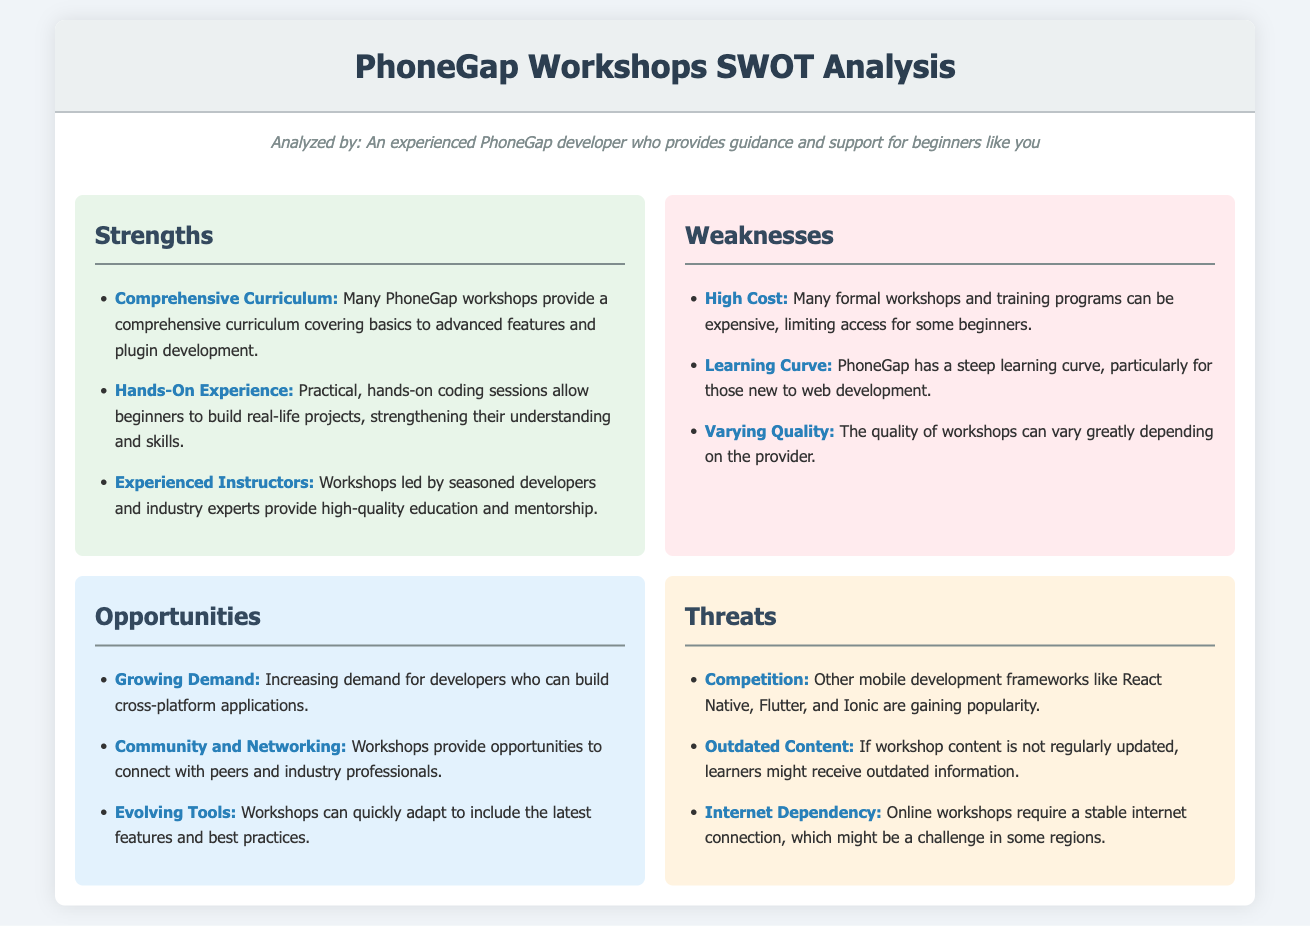What are the strengths listed in the SWOT analysis? The strengths section contains three main points about the workshops: comprehensive curriculum, hands-on experience, and experienced instructors.
Answer: Comprehensive Curriculum, Hands-On Experience, Experienced Instructors What is a listed weakness regarding the workshops? One of the weaknesses mentioned is that many formal workshops and training programs can be expensive, limiting access for some beginners.
Answer: High Cost Which opportunity highlights community benefits? The opportunities section discusses the chance to connect with peers and industry professionals as an advantage of the workshops.
Answer: Community and Networking What threat relates to competition? The screenshot mentions that other mobile development frameworks like React Native, Flutter, and Ionic are gaining popularity, posing a threat.
Answer: Competition How many strengths are mentioned in the analysis? The strengths section lists three distinct strengths regarding the workshops and training programs.
Answer: Three What is the learning curve associated with PhoneGap described in the weaknesses? It is noted in the document that PhoneGap has a steep learning curve, particularly for those who are new to web development.
Answer: Steep learning curve Which opportunity suggests adapting to technology trends? The workshops have the potential to quickly adapt to include the latest features and best practices as mentioned in the opportunities section.
Answer: Evolving Tools What is a potential issue for online workshops mentioned in the threats? The document points out that online workshops require a stable internet connection, which might be a challenge in some regions.
Answer: Internet Dependency 